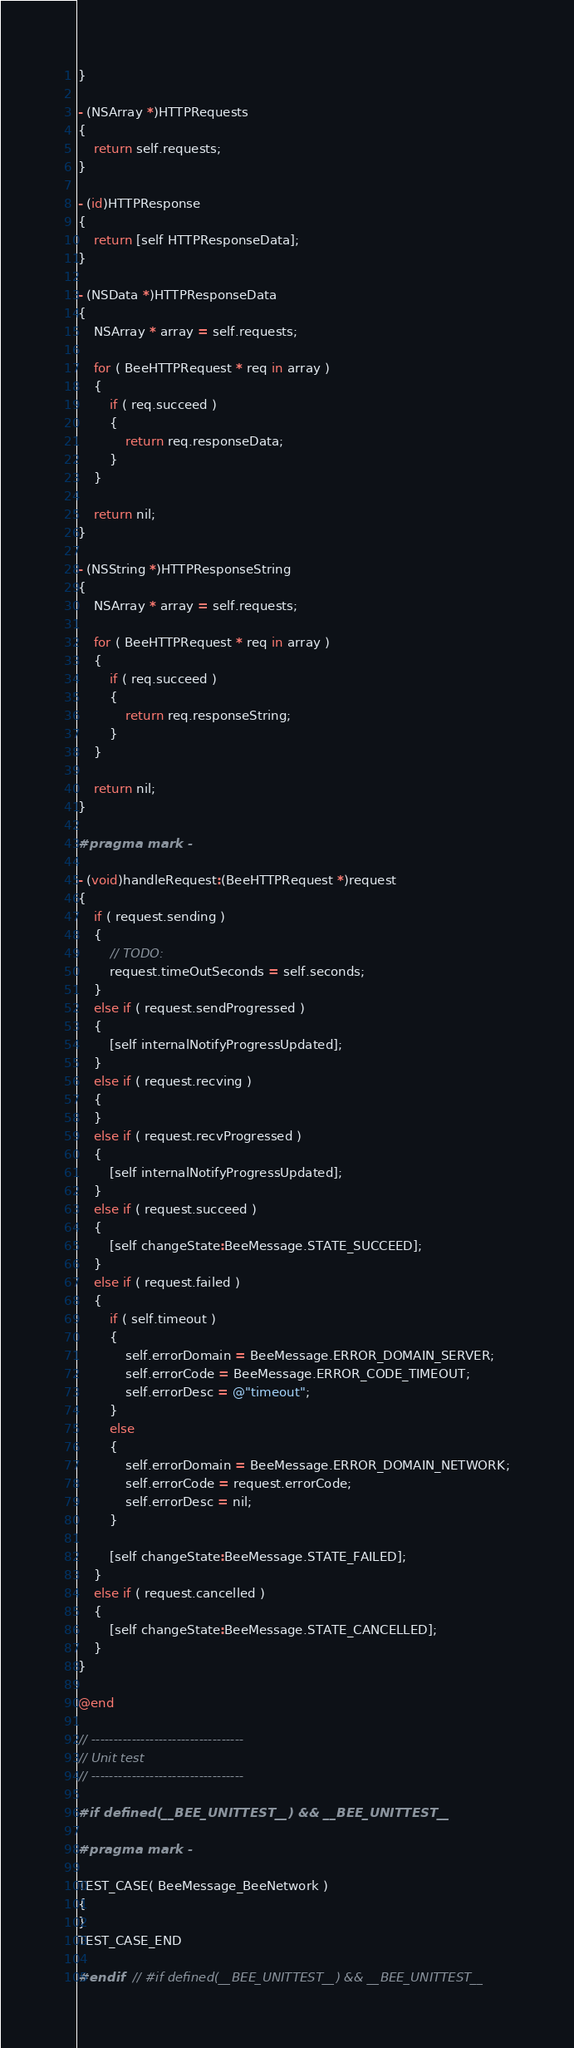Convert code to text. <code><loc_0><loc_0><loc_500><loc_500><_ObjectiveC_>}

- (NSArray *)HTTPRequests
{
	return self.requests;
}

- (id)HTTPResponse
{
	return [self HTTPResponseData];
}

- (NSData *)HTTPResponseData
{
	NSArray * array = self.requests;

	for ( BeeHTTPRequest * req in array )
	{
		if ( req.succeed )
		{
			return req.responseData;
		}
	}
	
	return nil;
}

- (NSString *)HTTPResponseString
{
	NSArray * array = self.requests;

	for ( BeeHTTPRequest * req in array )
	{
		if ( req.succeed )
		{
			return req.responseString;
		}
	}
	
	return nil;
}

#pragma mark -

- (void)handleRequest:(BeeHTTPRequest *)request
{
	if ( request.sending )
	{
		// TODO:
		request.timeOutSeconds = self.seconds;
	}
	else if ( request.sendProgressed )
	{
		[self internalNotifyProgressUpdated];
	}
	else if ( request.recving )
	{
	}
	else if ( request.recvProgressed )
	{
		[self internalNotifyProgressUpdated];
	}
	else if ( request.succeed )
	{
		[self changeState:BeeMessage.STATE_SUCCEED];
	}
	else if ( request.failed )
	{
		if ( self.timeout )
		{
			self.errorDomain = BeeMessage.ERROR_DOMAIN_SERVER;
			self.errorCode = BeeMessage.ERROR_CODE_TIMEOUT;
			self.errorDesc = @"timeout";
		}
		else
		{
			self.errorDomain = BeeMessage.ERROR_DOMAIN_NETWORK;
			self.errorCode = request.errorCode;
			self.errorDesc = nil;
		}

		[self changeState:BeeMessage.STATE_FAILED];
	}
	else if ( request.cancelled )
	{
		[self changeState:BeeMessage.STATE_CANCELLED];
	}
}

@end

// ----------------------------------
// Unit test
// ----------------------------------

#if defined(__BEE_UNITTEST__) && __BEE_UNITTEST__

#pragma mark -

TEST_CASE( BeeMessage_BeeNetwork )
{
}
TEST_CASE_END

#endif	// #if defined(__BEE_UNITTEST__) && __BEE_UNITTEST__
</code> 